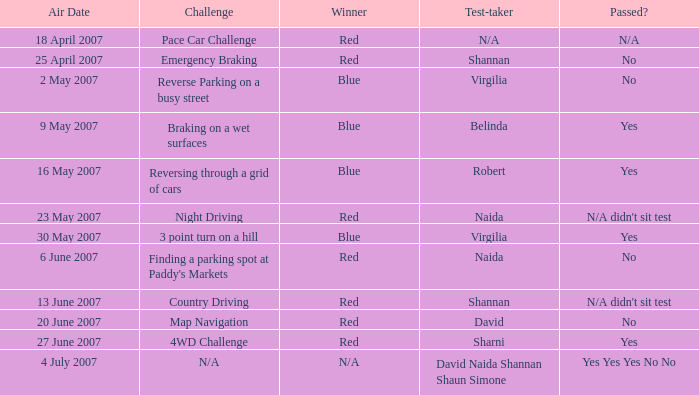What was the air date of robert's test-taking? 16 May 2007. 